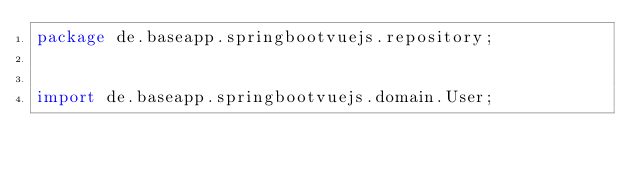<code> <loc_0><loc_0><loc_500><loc_500><_Java_>package de.baseapp.springbootvuejs.repository;


import de.baseapp.springbootvuejs.domain.User;</code> 